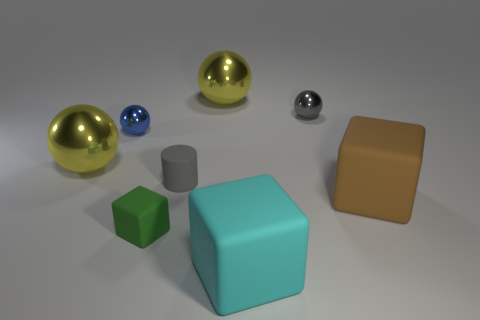Subtract all small gray shiny balls. How many balls are left? 3 Subtract all cyan cylinders. How many yellow spheres are left? 2 Subtract 1 blocks. How many blocks are left? 2 Add 1 small blue metal objects. How many objects exist? 9 Subtract all yellow balls. How many balls are left? 2 Subtract all cylinders. How many objects are left? 7 Subtract all purple blocks. Subtract all purple balls. How many blocks are left? 3 Subtract 0 green spheres. How many objects are left? 8 Subtract all green rubber things. Subtract all tiny gray matte cylinders. How many objects are left? 6 Add 1 green cubes. How many green cubes are left? 2 